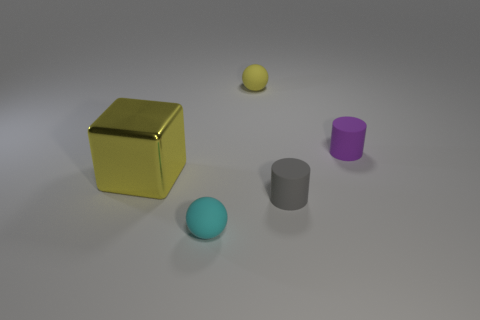Subtract 1 cylinders. How many cylinders are left? 1 Add 3 large objects. How many objects exist? 8 Subtract all gray cylinders. How many cylinders are left? 1 Subtract all gray cylinders. How many red spheres are left? 0 Subtract all small cyan matte spheres. Subtract all purple matte objects. How many objects are left? 3 Add 5 rubber cylinders. How many rubber cylinders are left? 7 Add 4 purple matte cylinders. How many purple matte cylinders exist? 5 Subtract 0 green cubes. How many objects are left? 5 Subtract all cubes. How many objects are left? 4 Subtract all brown cylinders. Subtract all gray cubes. How many cylinders are left? 2 